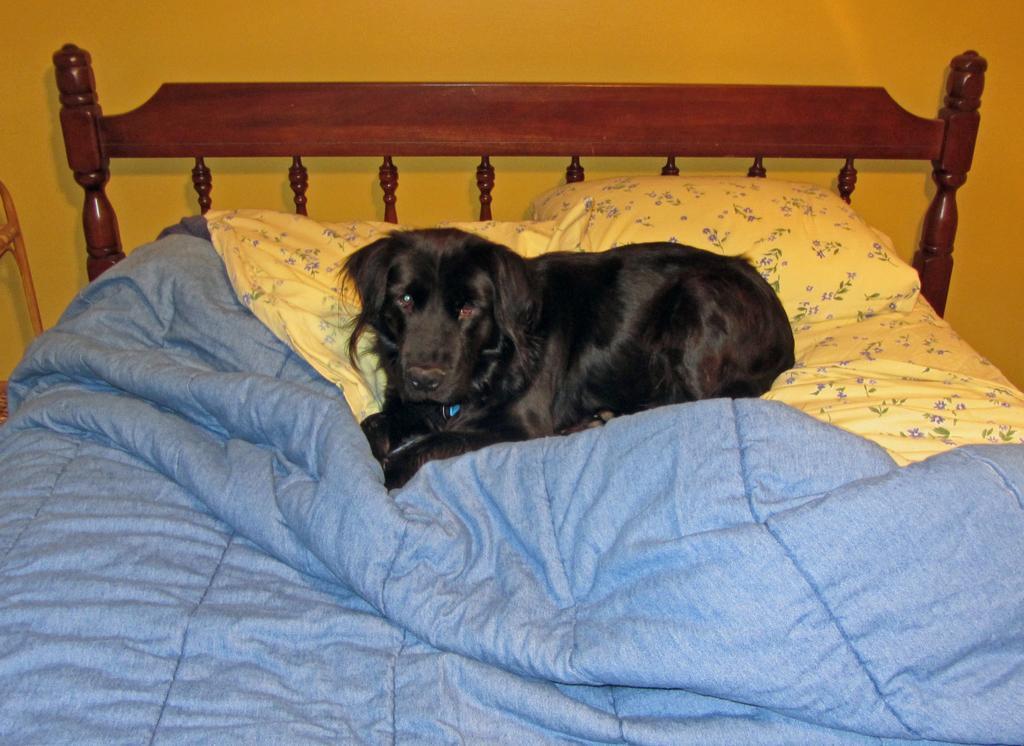Could you give a brief overview of what you see in this image? The picture is taken in a room. In the picture there is a bed, on the bed there are pillows, blanket and a dog. At the top, the wall is painted yellow. 